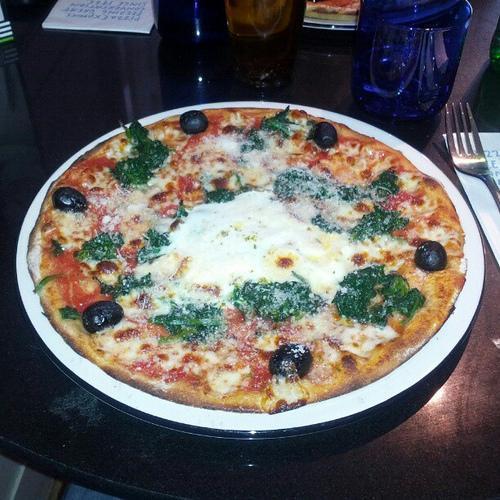How many pizzas are in the picture?
Give a very brief answer. 1. 